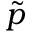<formula> <loc_0><loc_0><loc_500><loc_500>\tilde { p }</formula> 